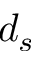<formula> <loc_0><loc_0><loc_500><loc_500>d _ { s }</formula> 